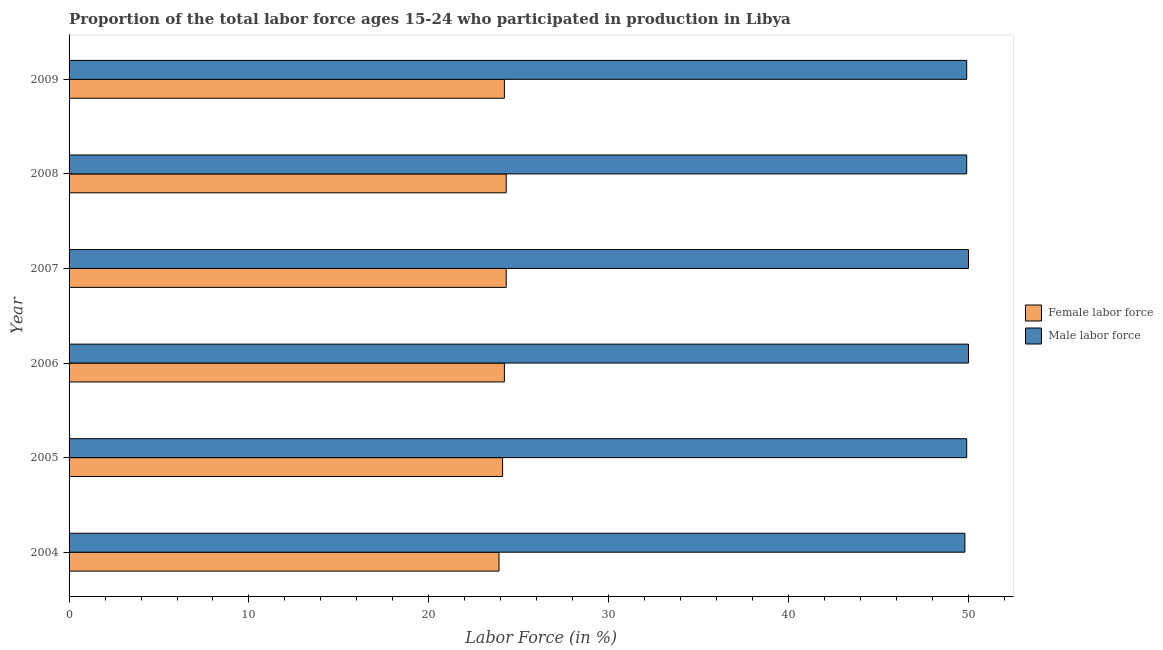How many different coloured bars are there?
Offer a terse response. 2. How many groups of bars are there?
Provide a short and direct response. 6. How many bars are there on the 1st tick from the top?
Offer a terse response. 2. What is the label of the 5th group of bars from the top?
Ensure brevity in your answer.  2005. What is the percentage of female labor force in 2009?
Your answer should be compact. 24.2. Across all years, what is the maximum percentage of male labour force?
Your response must be concise. 50. Across all years, what is the minimum percentage of male labour force?
Offer a very short reply. 49.8. What is the total percentage of female labor force in the graph?
Give a very brief answer. 145. What is the difference between the percentage of female labor force in 2007 and that in 2008?
Give a very brief answer. 0. What is the difference between the percentage of male labour force in 2009 and the percentage of female labor force in 2005?
Provide a short and direct response. 25.8. What is the average percentage of male labour force per year?
Offer a terse response. 49.92. In the year 2006, what is the difference between the percentage of male labour force and percentage of female labor force?
Offer a terse response. 25.8. What is the ratio of the percentage of female labor force in 2005 to that in 2009?
Make the answer very short. 1. Is the percentage of male labour force in 2007 less than that in 2009?
Keep it short and to the point. No. What is the difference between the highest and the second highest percentage of female labor force?
Keep it short and to the point. 0. In how many years, is the percentage of male labour force greater than the average percentage of male labour force taken over all years?
Offer a terse response. 2. What does the 1st bar from the top in 2004 represents?
Provide a succinct answer. Male labor force. What does the 2nd bar from the bottom in 2005 represents?
Provide a succinct answer. Male labor force. How many bars are there?
Make the answer very short. 12. How many years are there in the graph?
Ensure brevity in your answer.  6. What is the difference between two consecutive major ticks on the X-axis?
Offer a very short reply. 10. Are the values on the major ticks of X-axis written in scientific E-notation?
Provide a short and direct response. No. Does the graph contain grids?
Offer a terse response. No. Where does the legend appear in the graph?
Give a very brief answer. Center right. How are the legend labels stacked?
Your answer should be compact. Vertical. What is the title of the graph?
Your response must be concise. Proportion of the total labor force ages 15-24 who participated in production in Libya. What is the Labor Force (in %) of Female labor force in 2004?
Your answer should be very brief. 23.9. What is the Labor Force (in %) in Male labor force in 2004?
Ensure brevity in your answer.  49.8. What is the Labor Force (in %) in Female labor force in 2005?
Make the answer very short. 24.1. What is the Labor Force (in %) of Male labor force in 2005?
Offer a very short reply. 49.9. What is the Labor Force (in %) in Female labor force in 2006?
Your answer should be very brief. 24.2. What is the Labor Force (in %) in Male labor force in 2006?
Ensure brevity in your answer.  50. What is the Labor Force (in %) of Female labor force in 2007?
Your response must be concise. 24.3. What is the Labor Force (in %) of Male labor force in 2007?
Provide a short and direct response. 50. What is the Labor Force (in %) of Female labor force in 2008?
Offer a terse response. 24.3. What is the Labor Force (in %) in Male labor force in 2008?
Ensure brevity in your answer.  49.9. What is the Labor Force (in %) in Female labor force in 2009?
Provide a succinct answer. 24.2. What is the Labor Force (in %) of Male labor force in 2009?
Your answer should be compact. 49.9. Across all years, what is the maximum Labor Force (in %) in Female labor force?
Provide a short and direct response. 24.3. Across all years, what is the maximum Labor Force (in %) in Male labor force?
Offer a terse response. 50. Across all years, what is the minimum Labor Force (in %) of Female labor force?
Keep it short and to the point. 23.9. Across all years, what is the minimum Labor Force (in %) of Male labor force?
Provide a succinct answer. 49.8. What is the total Labor Force (in %) of Female labor force in the graph?
Your response must be concise. 145. What is the total Labor Force (in %) in Male labor force in the graph?
Your response must be concise. 299.5. What is the difference between the Labor Force (in %) of Male labor force in 2004 and that in 2005?
Make the answer very short. -0.1. What is the difference between the Labor Force (in %) of Female labor force in 2004 and that in 2006?
Your answer should be very brief. -0.3. What is the difference between the Labor Force (in %) in Female labor force in 2004 and that in 2007?
Your response must be concise. -0.4. What is the difference between the Labor Force (in %) in Male labor force in 2004 and that in 2007?
Offer a very short reply. -0.2. What is the difference between the Labor Force (in %) of Male labor force in 2004 and that in 2009?
Provide a succinct answer. -0.1. What is the difference between the Labor Force (in %) of Female labor force in 2005 and that in 2006?
Provide a short and direct response. -0.1. What is the difference between the Labor Force (in %) in Female labor force in 2005 and that in 2007?
Your answer should be compact. -0.2. What is the difference between the Labor Force (in %) in Male labor force in 2005 and that in 2007?
Your answer should be very brief. -0.1. What is the difference between the Labor Force (in %) in Female labor force in 2005 and that in 2009?
Your response must be concise. -0.1. What is the difference between the Labor Force (in %) of Male labor force in 2005 and that in 2009?
Your answer should be compact. 0. What is the difference between the Labor Force (in %) in Male labor force in 2006 and that in 2007?
Keep it short and to the point. 0. What is the difference between the Labor Force (in %) in Female labor force in 2006 and that in 2009?
Provide a succinct answer. 0. What is the difference between the Labor Force (in %) in Male labor force in 2006 and that in 2009?
Provide a succinct answer. 0.1. What is the difference between the Labor Force (in %) of Female labor force in 2007 and that in 2008?
Provide a short and direct response. 0. What is the difference between the Labor Force (in %) of Female labor force in 2008 and that in 2009?
Provide a succinct answer. 0.1. What is the difference between the Labor Force (in %) in Female labor force in 2004 and the Labor Force (in %) in Male labor force in 2006?
Provide a short and direct response. -26.1. What is the difference between the Labor Force (in %) of Female labor force in 2004 and the Labor Force (in %) of Male labor force in 2007?
Provide a short and direct response. -26.1. What is the difference between the Labor Force (in %) in Female labor force in 2005 and the Labor Force (in %) in Male labor force in 2006?
Make the answer very short. -25.9. What is the difference between the Labor Force (in %) in Female labor force in 2005 and the Labor Force (in %) in Male labor force in 2007?
Offer a terse response. -25.9. What is the difference between the Labor Force (in %) of Female labor force in 2005 and the Labor Force (in %) of Male labor force in 2008?
Offer a very short reply. -25.8. What is the difference between the Labor Force (in %) of Female labor force in 2005 and the Labor Force (in %) of Male labor force in 2009?
Give a very brief answer. -25.8. What is the difference between the Labor Force (in %) of Female labor force in 2006 and the Labor Force (in %) of Male labor force in 2007?
Offer a terse response. -25.8. What is the difference between the Labor Force (in %) of Female labor force in 2006 and the Labor Force (in %) of Male labor force in 2008?
Ensure brevity in your answer.  -25.7. What is the difference between the Labor Force (in %) in Female labor force in 2006 and the Labor Force (in %) in Male labor force in 2009?
Make the answer very short. -25.7. What is the difference between the Labor Force (in %) in Female labor force in 2007 and the Labor Force (in %) in Male labor force in 2008?
Keep it short and to the point. -25.6. What is the difference between the Labor Force (in %) of Female labor force in 2007 and the Labor Force (in %) of Male labor force in 2009?
Make the answer very short. -25.6. What is the difference between the Labor Force (in %) in Female labor force in 2008 and the Labor Force (in %) in Male labor force in 2009?
Make the answer very short. -25.6. What is the average Labor Force (in %) in Female labor force per year?
Provide a short and direct response. 24.17. What is the average Labor Force (in %) of Male labor force per year?
Offer a very short reply. 49.92. In the year 2004, what is the difference between the Labor Force (in %) in Female labor force and Labor Force (in %) in Male labor force?
Provide a short and direct response. -25.9. In the year 2005, what is the difference between the Labor Force (in %) in Female labor force and Labor Force (in %) in Male labor force?
Provide a short and direct response. -25.8. In the year 2006, what is the difference between the Labor Force (in %) of Female labor force and Labor Force (in %) of Male labor force?
Keep it short and to the point. -25.8. In the year 2007, what is the difference between the Labor Force (in %) of Female labor force and Labor Force (in %) of Male labor force?
Offer a terse response. -25.7. In the year 2008, what is the difference between the Labor Force (in %) in Female labor force and Labor Force (in %) in Male labor force?
Offer a terse response. -25.6. In the year 2009, what is the difference between the Labor Force (in %) in Female labor force and Labor Force (in %) in Male labor force?
Offer a terse response. -25.7. What is the ratio of the Labor Force (in %) of Male labor force in 2004 to that in 2005?
Provide a short and direct response. 1. What is the ratio of the Labor Force (in %) in Female labor force in 2004 to that in 2006?
Provide a short and direct response. 0.99. What is the ratio of the Labor Force (in %) in Female labor force in 2004 to that in 2007?
Provide a succinct answer. 0.98. What is the ratio of the Labor Force (in %) in Male labor force in 2004 to that in 2007?
Offer a terse response. 1. What is the ratio of the Labor Force (in %) of Female labor force in 2004 to that in 2008?
Your response must be concise. 0.98. What is the ratio of the Labor Force (in %) of Female labor force in 2004 to that in 2009?
Offer a very short reply. 0.99. What is the ratio of the Labor Force (in %) of Female labor force in 2005 to that in 2007?
Offer a terse response. 0.99. What is the ratio of the Labor Force (in %) in Male labor force in 2005 to that in 2007?
Your response must be concise. 1. What is the ratio of the Labor Force (in %) in Female labor force in 2006 to that in 2007?
Your answer should be very brief. 1. What is the ratio of the Labor Force (in %) in Female labor force in 2006 to that in 2008?
Your response must be concise. 1. What is the ratio of the Labor Force (in %) of Male labor force in 2006 to that in 2008?
Provide a succinct answer. 1. What is the ratio of the Labor Force (in %) in Male labor force in 2007 to that in 2008?
Ensure brevity in your answer.  1. What is the ratio of the Labor Force (in %) of Female labor force in 2007 to that in 2009?
Ensure brevity in your answer.  1. What is the ratio of the Labor Force (in %) in Female labor force in 2008 to that in 2009?
Offer a terse response. 1. What is the difference between the highest and the second highest Labor Force (in %) of Female labor force?
Your answer should be compact. 0. What is the difference between the highest and the second highest Labor Force (in %) in Male labor force?
Make the answer very short. 0. 